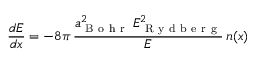Convert formula to latex. <formula><loc_0><loc_0><loc_500><loc_500>\frac { d E } { d x } = - 8 \pi \, \frac { a _ { B o h r } ^ { 2 } \, E _ { R y d b e r g } ^ { 2 } } { E } \, n ( x )</formula> 